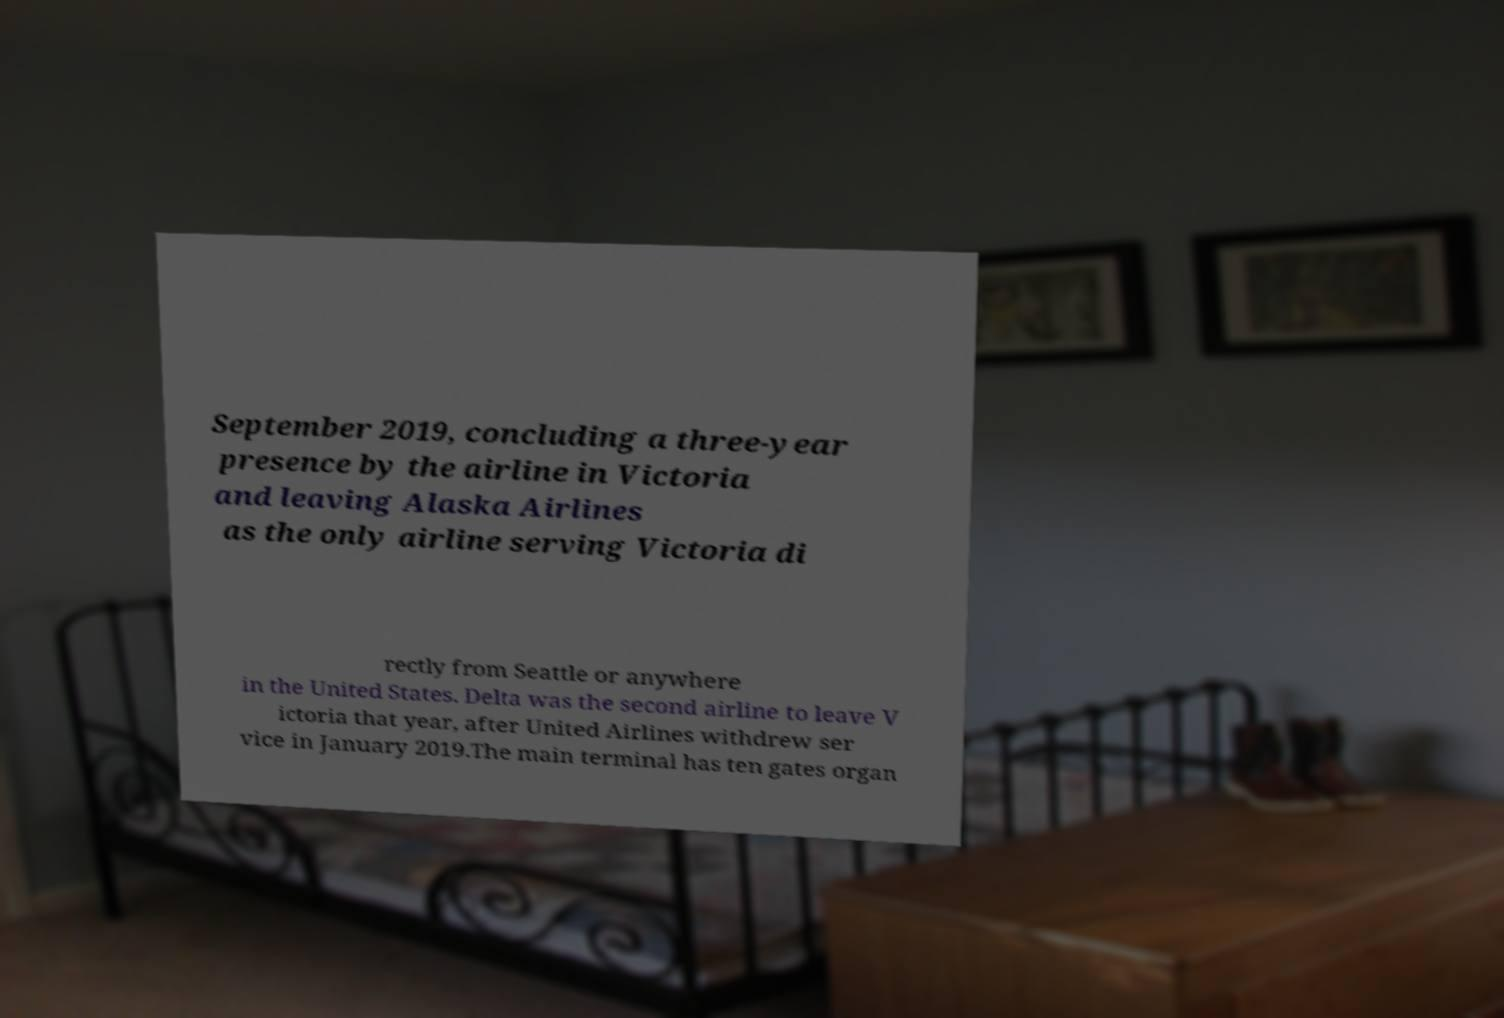Could you assist in decoding the text presented in this image and type it out clearly? September 2019, concluding a three-year presence by the airline in Victoria and leaving Alaska Airlines as the only airline serving Victoria di rectly from Seattle or anywhere in the United States. Delta was the second airline to leave V ictoria that year, after United Airlines withdrew ser vice in January 2019.The main terminal has ten gates organ 